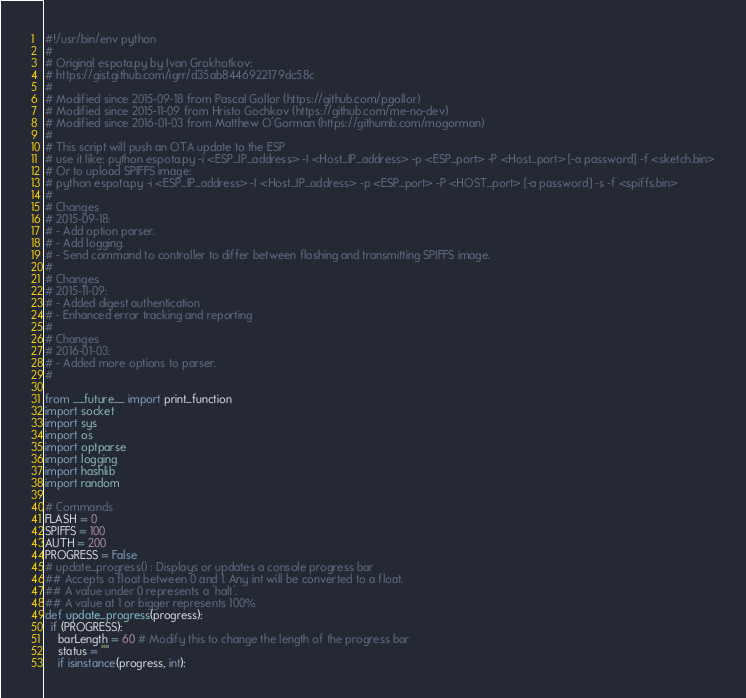<code> <loc_0><loc_0><loc_500><loc_500><_Python_>#!/usr/bin/env python
#
# Original espota.py by Ivan Grokhotkov:
# https://gist.github.com/igrr/d35ab8446922179dc58c
#
# Modified since 2015-09-18 from Pascal Gollor (https://github.com/pgollor)
# Modified since 2015-11-09 from Hristo Gochkov (https://github.com/me-no-dev)
# Modified since 2016-01-03 from Matthew O'Gorman (https://githumb.com/mogorman)
#
# This script will push an OTA update to the ESP
# use it like: python espota.py -i <ESP_IP_address> -I <Host_IP_address> -p <ESP_port> -P <Host_port> [-a password] -f <sketch.bin>
# Or to upload SPIFFS image:
# python espota.py -i <ESP_IP_address> -I <Host_IP_address> -p <ESP_port> -P <HOST_port> [-a password] -s -f <spiffs.bin>
#
# Changes
# 2015-09-18:
# - Add option parser.
# - Add logging.
# - Send command to controller to differ between flashing and transmitting SPIFFS image.
#
# Changes
# 2015-11-09:
# - Added digest authentication
# - Enhanced error tracking and reporting
#
# Changes
# 2016-01-03:
# - Added more options to parser.
#

from __future__ import print_function
import socket
import sys
import os
import optparse
import logging
import hashlib
import random

# Commands
FLASH = 0
SPIFFS = 100
AUTH = 200
PROGRESS = False
# update_progress() : Displays or updates a console progress bar
## Accepts a float between 0 and 1. Any int will be converted to a float.
## A value under 0 represents a 'halt'.
## A value at 1 or bigger represents 100%
def update_progress(progress):
  if (PROGRESS):
    barLength = 60 # Modify this to change the length of the progress bar
    status = ""
    if isinstance(progress, int):</code> 